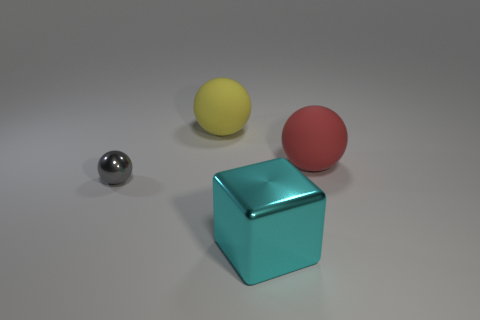Subtract all large spheres. How many spheres are left? 1 Subtract all green spheres. Subtract all red blocks. How many spheres are left? 3 Add 1 tiny metal balls. How many objects exist? 5 Subtract 1 yellow spheres. How many objects are left? 3 Subtract all spheres. How many objects are left? 1 Subtract all yellow matte things. Subtract all red rubber spheres. How many objects are left? 2 Add 2 red rubber things. How many red rubber things are left? 3 Add 2 tiny red cylinders. How many tiny red cylinders exist? 2 